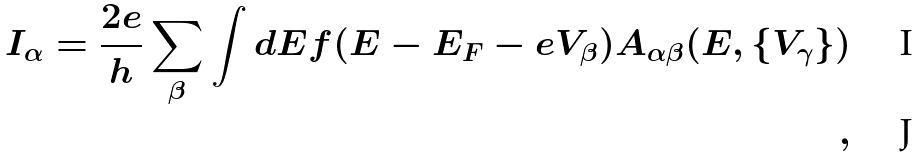<formula> <loc_0><loc_0><loc_500><loc_500>I _ { \alpha } = \frac { 2 e } { h } \sum _ { \beta } \int d E f ( E - E _ { F } - e V _ { \beta } ) A _ { \alpha \beta } ( E , \{ V _ { \gamma } \} ) \\ ,</formula> 